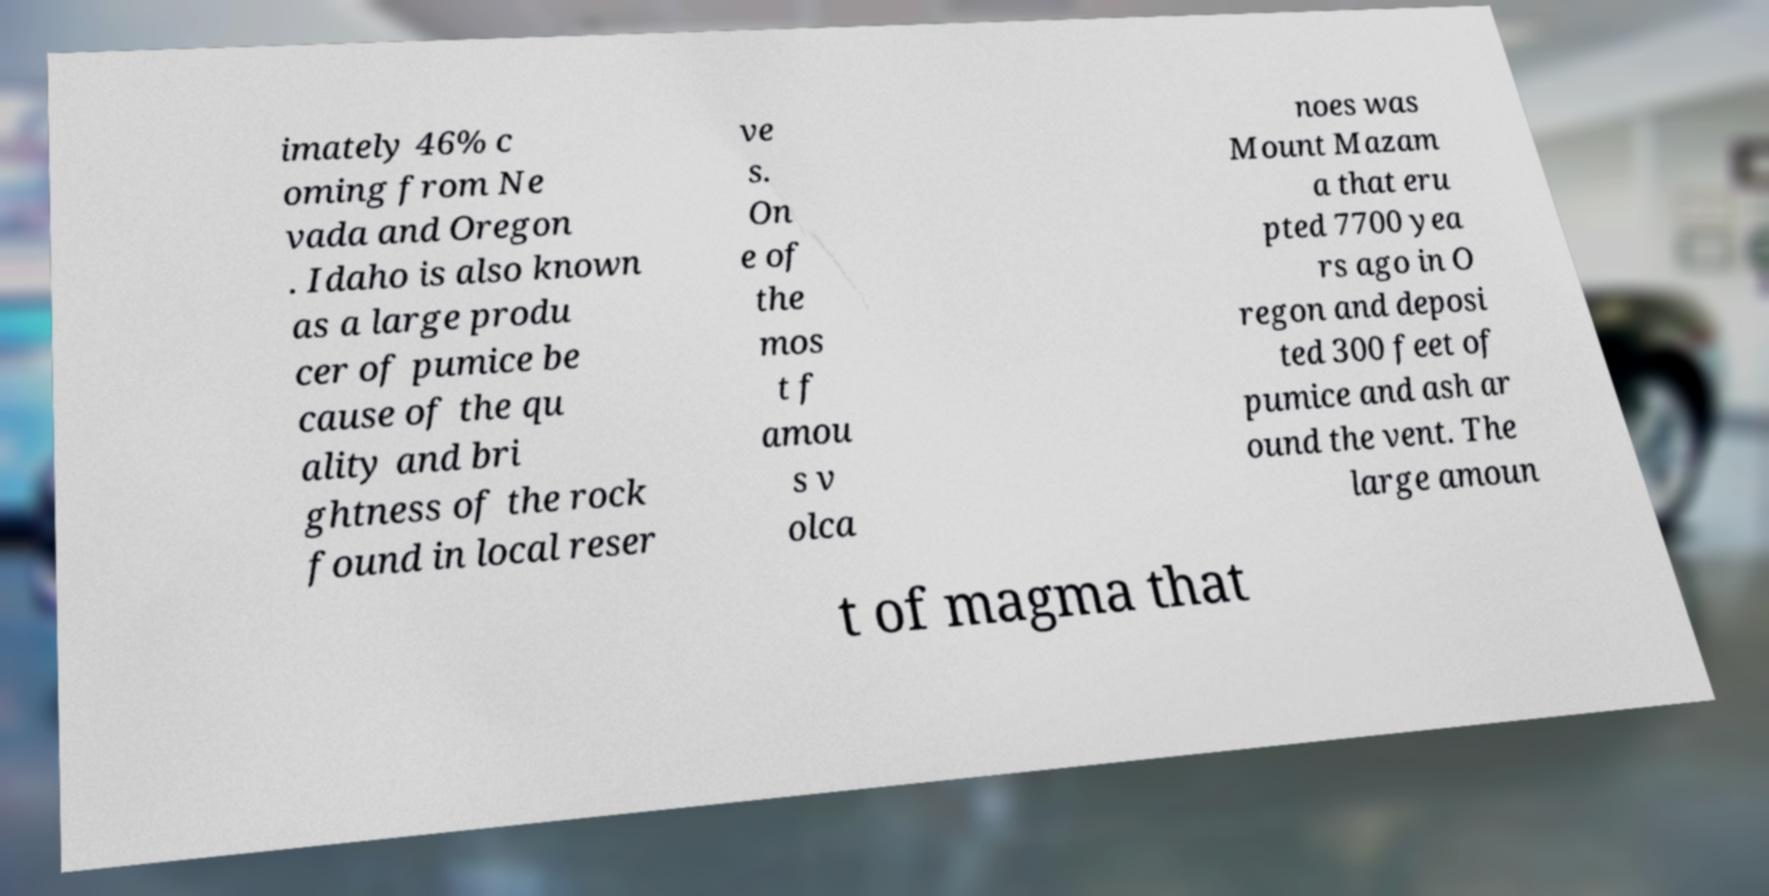Can you accurately transcribe the text from the provided image for me? imately 46% c oming from Ne vada and Oregon . Idaho is also known as a large produ cer of pumice be cause of the qu ality and bri ghtness of the rock found in local reser ve s. On e of the mos t f amou s v olca noes was Mount Mazam a that eru pted 7700 yea rs ago in O regon and deposi ted 300 feet of pumice and ash ar ound the vent. The large amoun t of magma that 